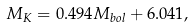<formula> <loc_0><loc_0><loc_500><loc_500>M _ { K } = 0 . 4 9 4 M _ { b o l } + 6 . 0 4 1 ,</formula> 